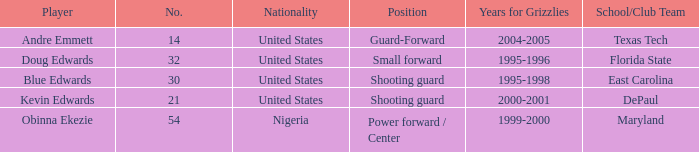Which school/club team did blue edwards play for East Carolina. 